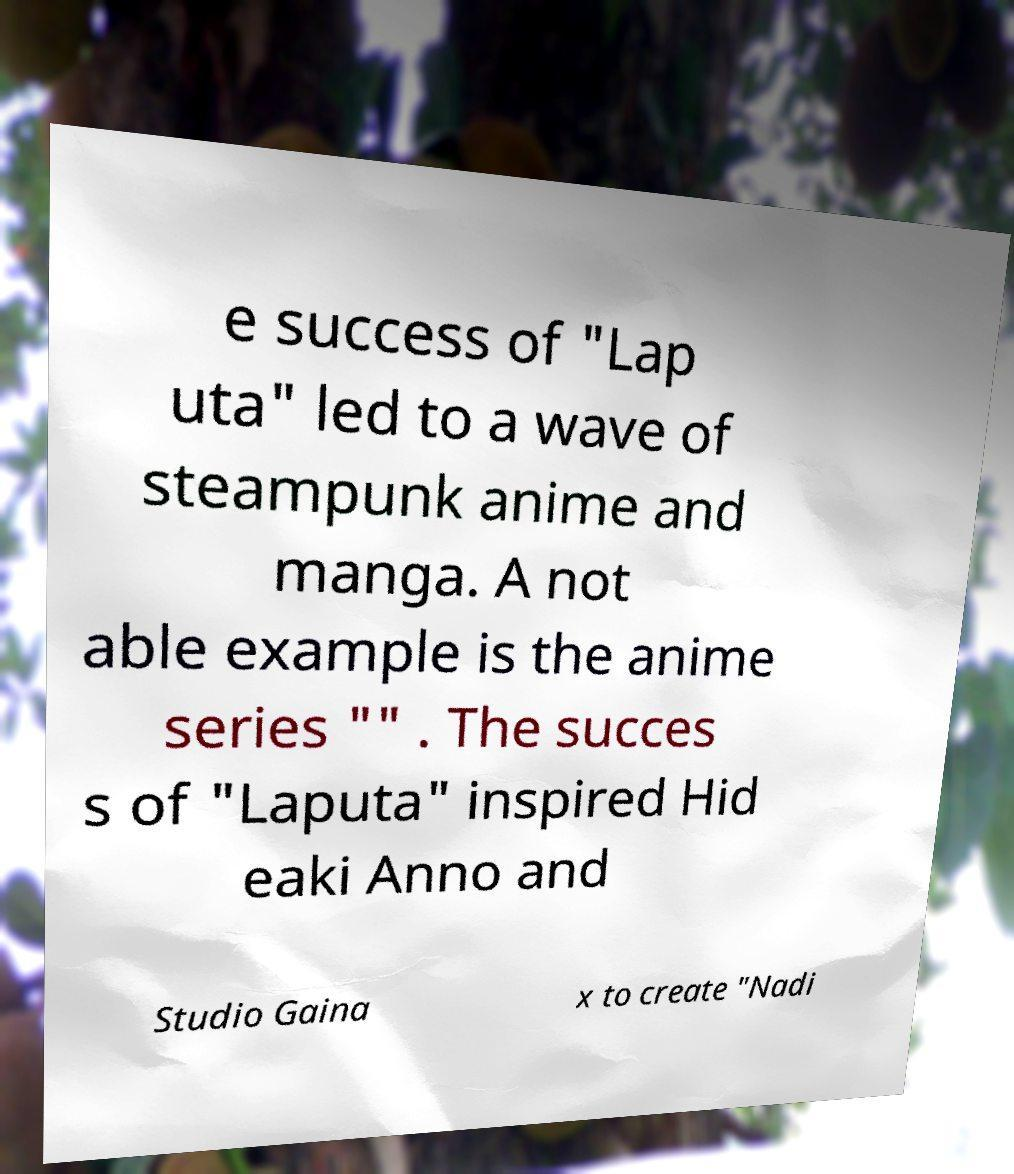Can you accurately transcribe the text from the provided image for me? e success of "Lap uta" led to a wave of steampunk anime and manga. A not able example is the anime series "" . The succes s of "Laputa" inspired Hid eaki Anno and Studio Gaina x to create "Nadi 